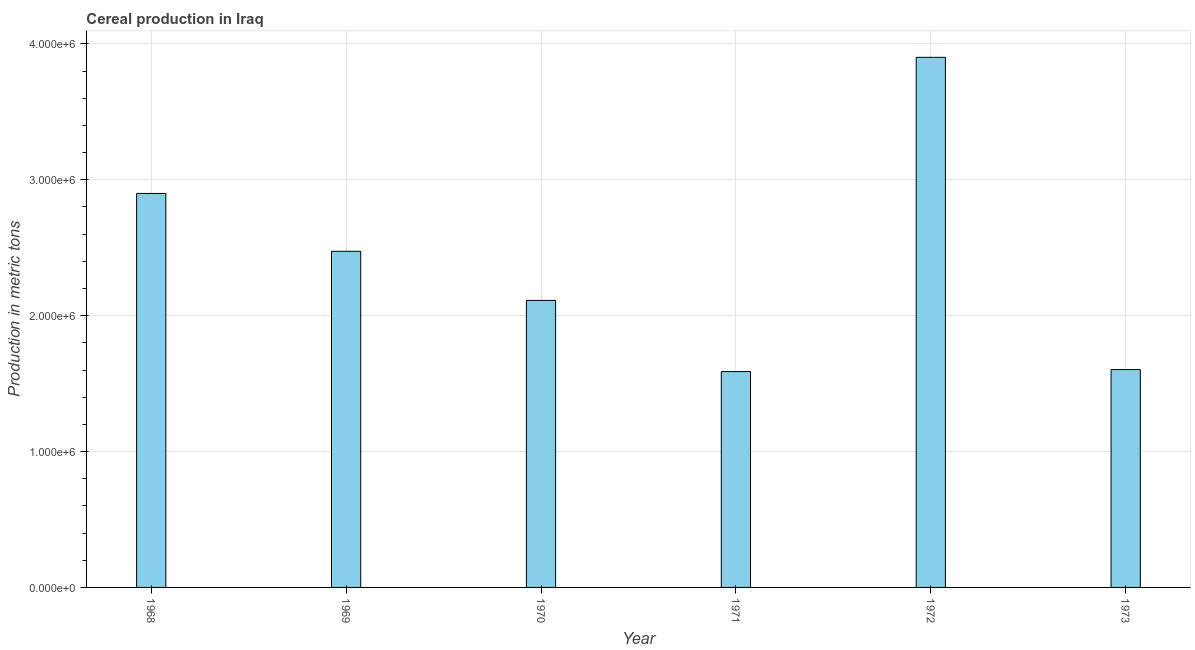Does the graph contain any zero values?
Offer a very short reply. No. Does the graph contain grids?
Your answer should be compact. Yes. What is the title of the graph?
Keep it short and to the point. Cereal production in Iraq. What is the label or title of the Y-axis?
Offer a very short reply. Production in metric tons. What is the cereal production in 1968?
Your answer should be compact. 2.90e+06. Across all years, what is the maximum cereal production?
Ensure brevity in your answer.  3.90e+06. Across all years, what is the minimum cereal production?
Offer a very short reply. 1.59e+06. In which year was the cereal production maximum?
Your response must be concise. 1972. What is the sum of the cereal production?
Provide a succinct answer. 1.46e+07. What is the difference between the cereal production in 1968 and 1971?
Provide a short and direct response. 1.31e+06. What is the average cereal production per year?
Your answer should be very brief. 2.43e+06. What is the median cereal production?
Give a very brief answer. 2.29e+06. Do a majority of the years between 1968 and 1971 (inclusive) have cereal production greater than 1200000 metric tons?
Your answer should be very brief. Yes. What is the ratio of the cereal production in 1971 to that in 1972?
Make the answer very short. 0.41. What is the difference between the highest and the second highest cereal production?
Keep it short and to the point. 1.00e+06. What is the difference between the highest and the lowest cereal production?
Offer a terse response. 2.31e+06. In how many years, is the cereal production greater than the average cereal production taken over all years?
Keep it short and to the point. 3. How many bars are there?
Keep it short and to the point. 6. What is the Production in metric tons in 1968?
Your answer should be very brief. 2.90e+06. What is the Production in metric tons in 1969?
Your response must be concise. 2.47e+06. What is the Production in metric tons of 1970?
Offer a very short reply. 2.11e+06. What is the Production in metric tons in 1971?
Offer a terse response. 1.59e+06. What is the Production in metric tons of 1972?
Your answer should be compact. 3.90e+06. What is the Production in metric tons of 1973?
Your answer should be very brief. 1.60e+06. What is the difference between the Production in metric tons in 1968 and 1969?
Ensure brevity in your answer.  4.26e+05. What is the difference between the Production in metric tons in 1968 and 1970?
Your response must be concise. 7.87e+05. What is the difference between the Production in metric tons in 1968 and 1971?
Ensure brevity in your answer.  1.31e+06. What is the difference between the Production in metric tons in 1968 and 1972?
Offer a terse response. -1.00e+06. What is the difference between the Production in metric tons in 1968 and 1973?
Your response must be concise. 1.30e+06. What is the difference between the Production in metric tons in 1969 and 1970?
Provide a short and direct response. 3.61e+05. What is the difference between the Production in metric tons in 1969 and 1971?
Provide a succinct answer. 8.85e+05. What is the difference between the Production in metric tons in 1969 and 1972?
Your answer should be compact. -1.43e+06. What is the difference between the Production in metric tons in 1969 and 1973?
Offer a very short reply. 8.70e+05. What is the difference between the Production in metric tons in 1970 and 1971?
Ensure brevity in your answer.  5.24e+05. What is the difference between the Production in metric tons in 1970 and 1972?
Your response must be concise. -1.79e+06. What is the difference between the Production in metric tons in 1970 and 1973?
Provide a short and direct response. 5.09e+05. What is the difference between the Production in metric tons in 1971 and 1972?
Offer a very short reply. -2.31e+06. What is the difference between the Production in metric tons in 1971 and 1973?
Your response must be concise. -1.48e+04. What is the difference between the Production in metric tons in 1972 and 1973?
Offer a terse response. 2.30e+06. What is the ratio of the Production in metric tons in 1968 to that in 1969?
Your answer should be very brief. 1.17. What is the ratio of the Production in metric tons in 1968 to that in 1970?
Keep it short and to the point. 1.37. What is the ratio of the Production in metric tons in 1968 to that in 1971?
Your answer should be compact. 1.82. What is the ratio of the Production in metric tons in 1968 to that in 1972?
Ensure brevity in your answer.  0.74. What is the ratio of the Production in metric tons in 1968 to that in 1973?
Your answer should be compact. 1.81. What is the ratio of the Production in metric tons in 1969 to that in 1970?
Ensure brevity in your answer.  1.17. What is the ratio of the Production in metric tons in 1969 to that in 1971?
Your answer should be compact. 1.56. What is the ratio of the Production in metric tons in 1969 to that in 1972?
Offer a very short reply. 0.63. What is the ratio of the Production in metric tons in 1969 to that in 1973?
Ensure brevity in your answer.  1.54. What is the ratio of the Production in metric tons in 1970 to that in 1971?
Offer a terse response. 1.33. What is the ratio of the Production in metric tons in 1970 to that in 1972?
Provide a succinct answer. 0.54. What is the ratio of the Production in metric tons in 1970 to that in 1973?
Offer a terse response. 1.32. What is the ratio of the Production in metric tons in 1971 to that in 1972?
Offer a very short reply. 0.41. What is the ratio of the Production in metric tons in 1972 to that in 1973?
Provide a succinct answer. 2.43. 